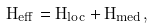Convert formula to latex. <formula><loc_0><loc_0><loc_500><loc_500>H _ { e f f } = H _ { l o c } + H _ { m e d } ,</formula> 